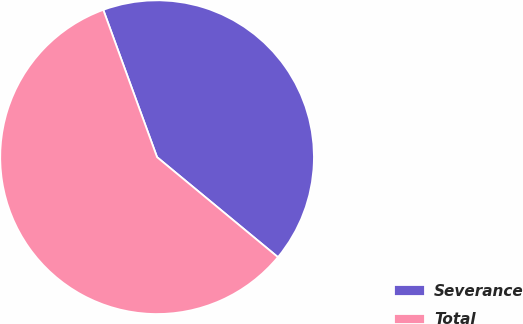<chart> <loc_0><loc_0><loc_500><loc_500><pie_chart><fcel>Severance<fcel>Total<nl><fcel>41.57%<fcel>58.43%<nl></chart> 